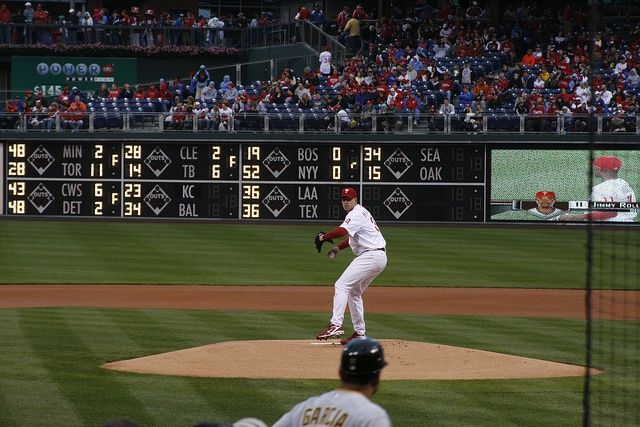Describe the objects in this image and their specific colors. I can see tv in black, darkgray, gray, and teal tones, people in black, lavender, darkgray, gray, and darkgreen tones, people in black, darkgray, and gray tones, people in black, gray, darkgray, and teal tones, and people in black, gray, and maroon tones in this image. 